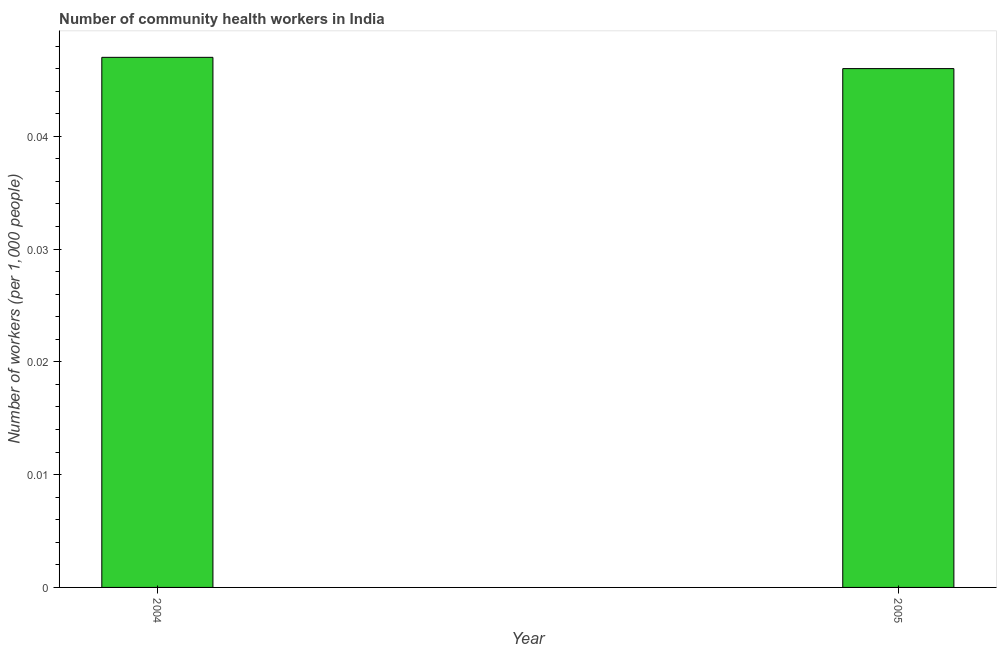What is the title of the graph?
Make the answer very short. Number of community health workers in India. What is the label or title of the X-axis?
Give a very brief answer. Year. What is the label or title of the Y-axis?
Your response must be concise. Number of workers (per 1,0 people). What is the number of community health workers in 2004?
Provide a short and direct response. 0.05. Across all years, what is the maximum number of community health workers?
Give a very brief answer. 0.05. Across all years, what is the minimum number of community health workers?
Offer a terse response. 0.05. In which year was the number of community health workers maximum?
Your answer should be compact. 2004. What is the sum of the number of community health workers?
Give a very brief answer. 0.09. What is the average number of community health workers per year?
Provide a short and direct response. 0.05. What is the median number of community health workers?
Your response must be concise. 0.05. What is the ratio of the number of community health workers in 2004 to that in 2005?
Keep it short and to the point. 1.02. Is the number of community health workers in 2004 less than that in 2005?
Your answer should be very brief. No. How many bars are there?
Provide a succinct answer. 2. Are the values on the major ticks of Y-axis written in scientific E-notation?
Provide a short and direct response. No. What is the Number of workers (per 1,000 people) in 2004?
Provide a succinct answer. 0.05. What is the Number of workers (per 1,000 people) of 2005?
Provide a succinct answer. 0.05. What is the difference between the Number of workers (per 1,000 people) in 2004 and 2005?
Your answer should be compact. 0. What is the ratio of the Number of workers (per 1,000 people) in 2004 to that in 2005?
Give a very brief answer. 1.02. 